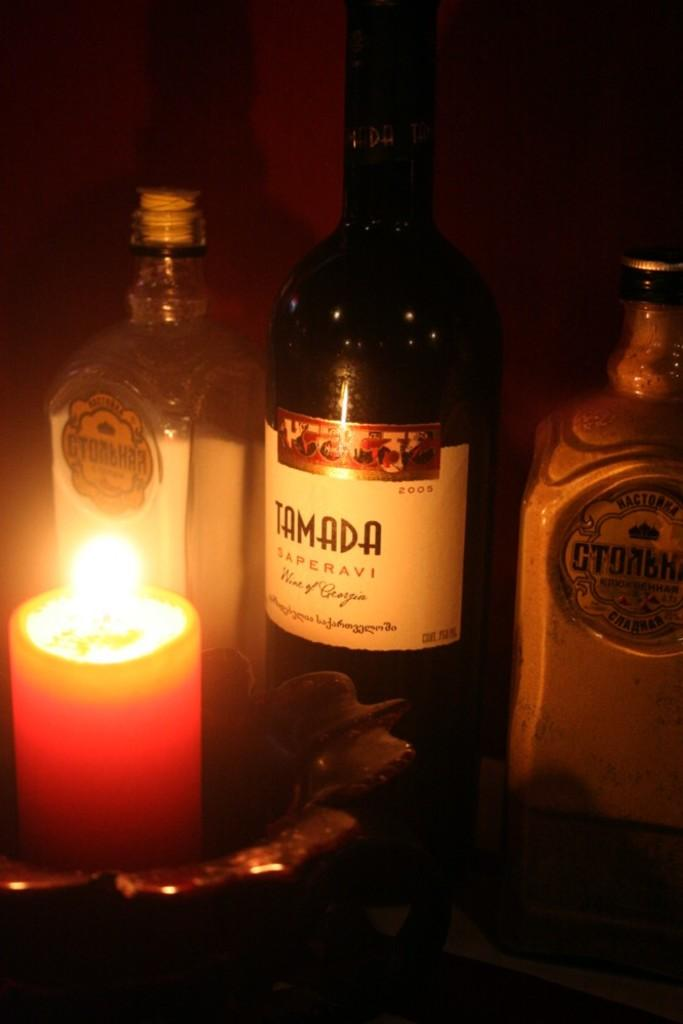<image>
Offer a succinct explanation of the picture presented. The table is lit with candle light and there is a bottle of Tamada wine displayed. 